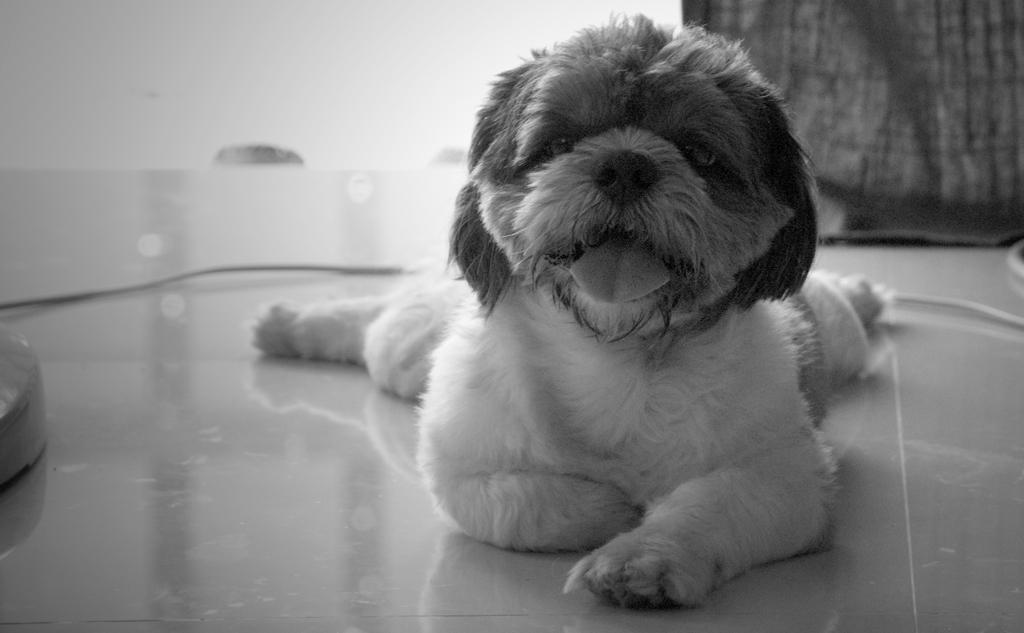What type of animal is present in the image? There is a dog in the image. What is the dog doing in the image? The dog is laying on a table. What is the color scheme of the image? The image is in black and white. Where is the playground located in the image? There is no playground present in the image. Can you tell me what the judge is wearing in the image? There is no judge present in the image. How many oranges can be seen in the image? There are no oranges present in the image. 